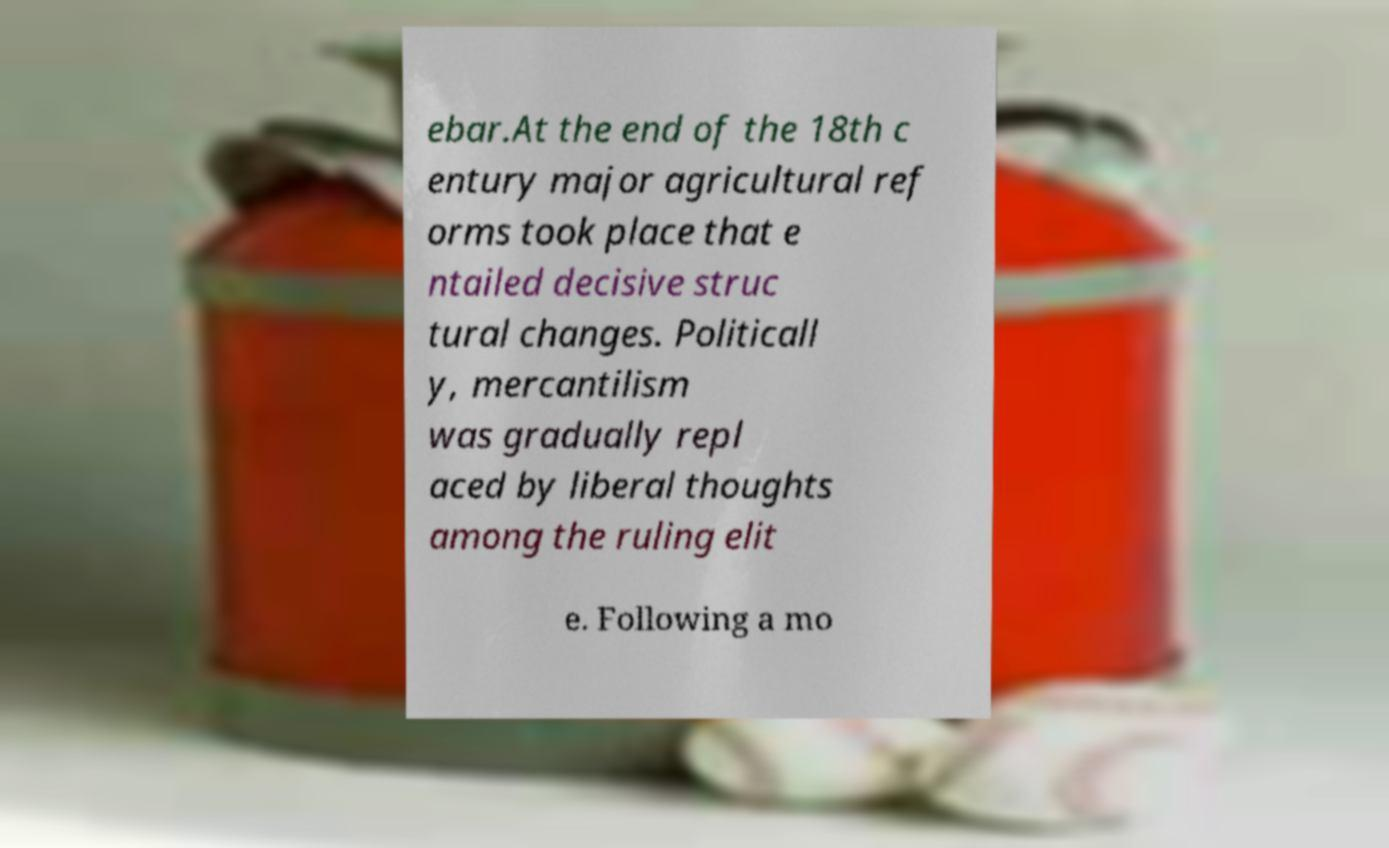I need the written content from this picture converted into text. Can you do that? ebar.At the end of the 18th c entury major agricultural ref orms took place that e ntailed decisive struc tural changes. Politicall y, mercantilism was gradually repl aced by liberal thoughts among the ruling elit e. Following a mo 